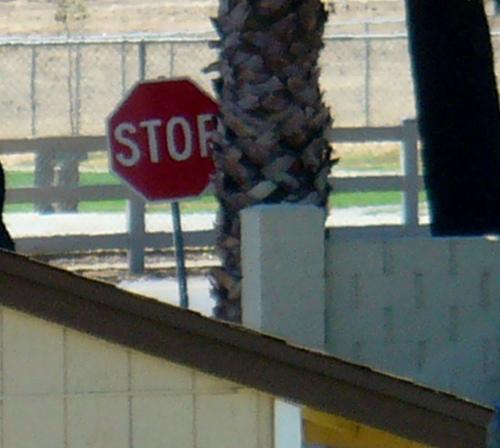Is this an obeyed sign?
Quick response, please. Yes. What word is on the red sign?
Concise answer only. Stop. Is the sign next to a tree?
Concise answer only. Yes. 